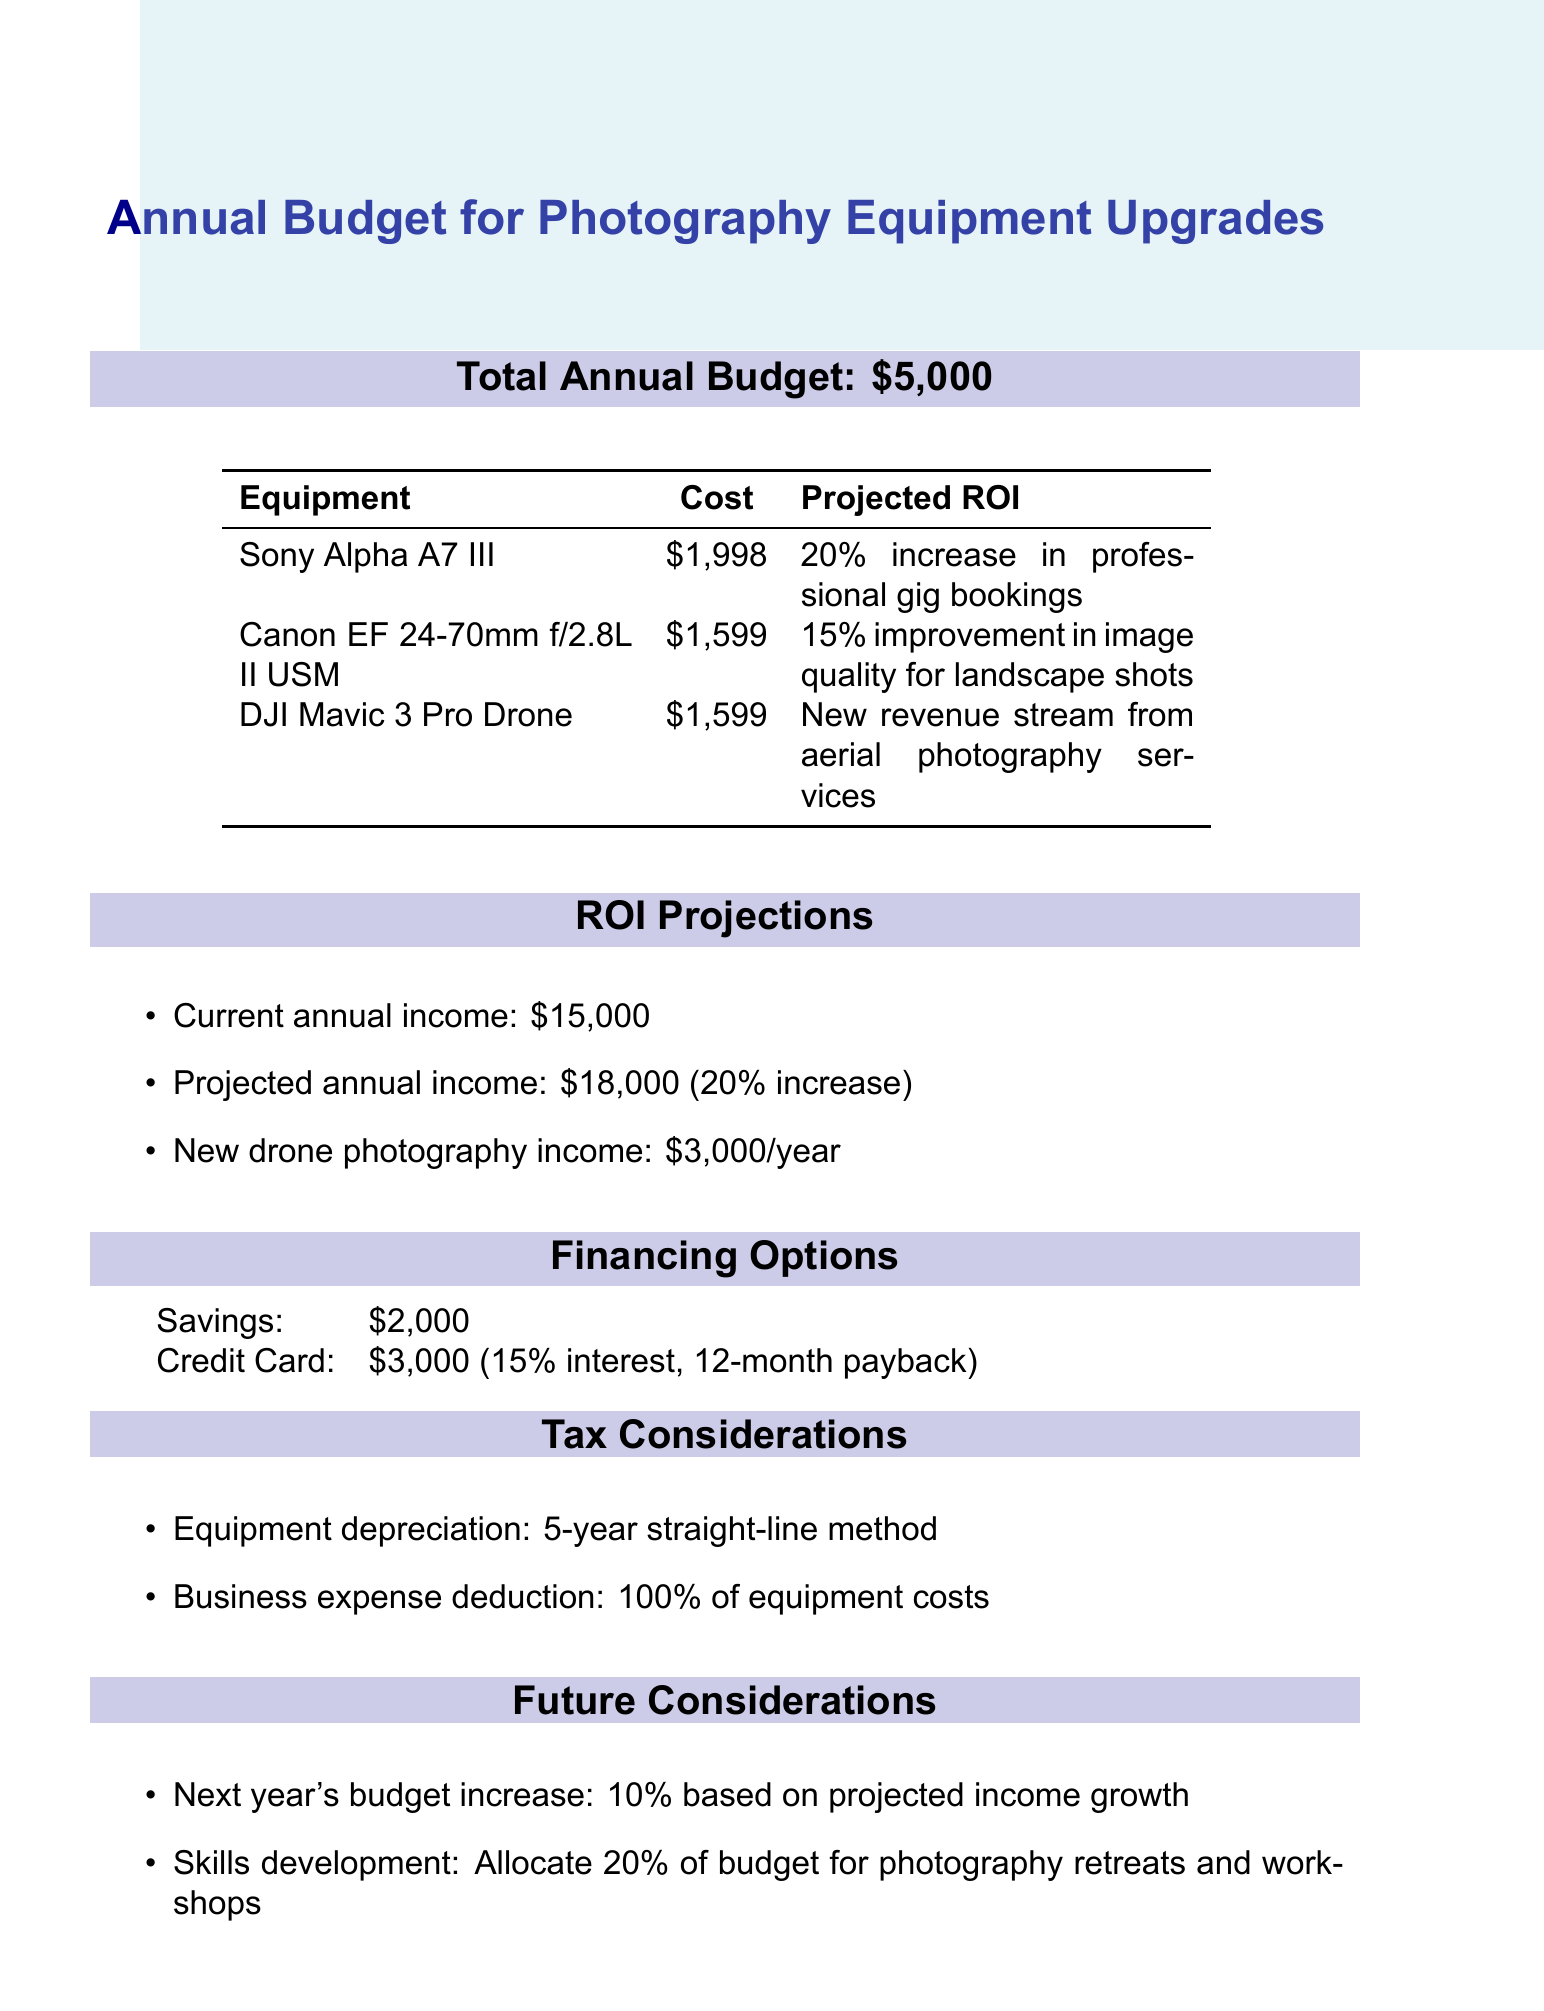What is the total annual budget? The total annual budget is stated clearly in the document.
Answer: $5,000 What is the cost of the Sony Alpha A7 III camera? The document lists the cost of the Sony Alpha A7 III camera, which is provided in the equipment upgrades section.
Answer: $1,998 What is the projected ROI for the Canon EF 24-70mm lens? The projected ROI for the Canon EF 24-70mm lens is included in the table presenting the equipment upgrades.
Answer: 15% improvement in image quality for landscape shots What is the projected annual income from new drone photography services? The projected annual income from the drone photography services is summarized under the ROI projections section.
Answer: $3,000 What percentage increase in professional gig bookings is projected from the camera upgrade? The document specifies the percentage increase for professional gig bookings as part of the camera's projected ROI.
Answer: 20% How much is allocated for skills development next year? The document outlines future considerations, including the allocation for skills development in the budget.
Answer: 20% What is the total savings amount available for equipment upgrades? The total savings amount is specified under the financing options section of the document.
Answer: $2,000 What is the interest rate associated with the credit card financing option? The interest rate is stated clearly in the financing options section of the document.
Answer: 15% 